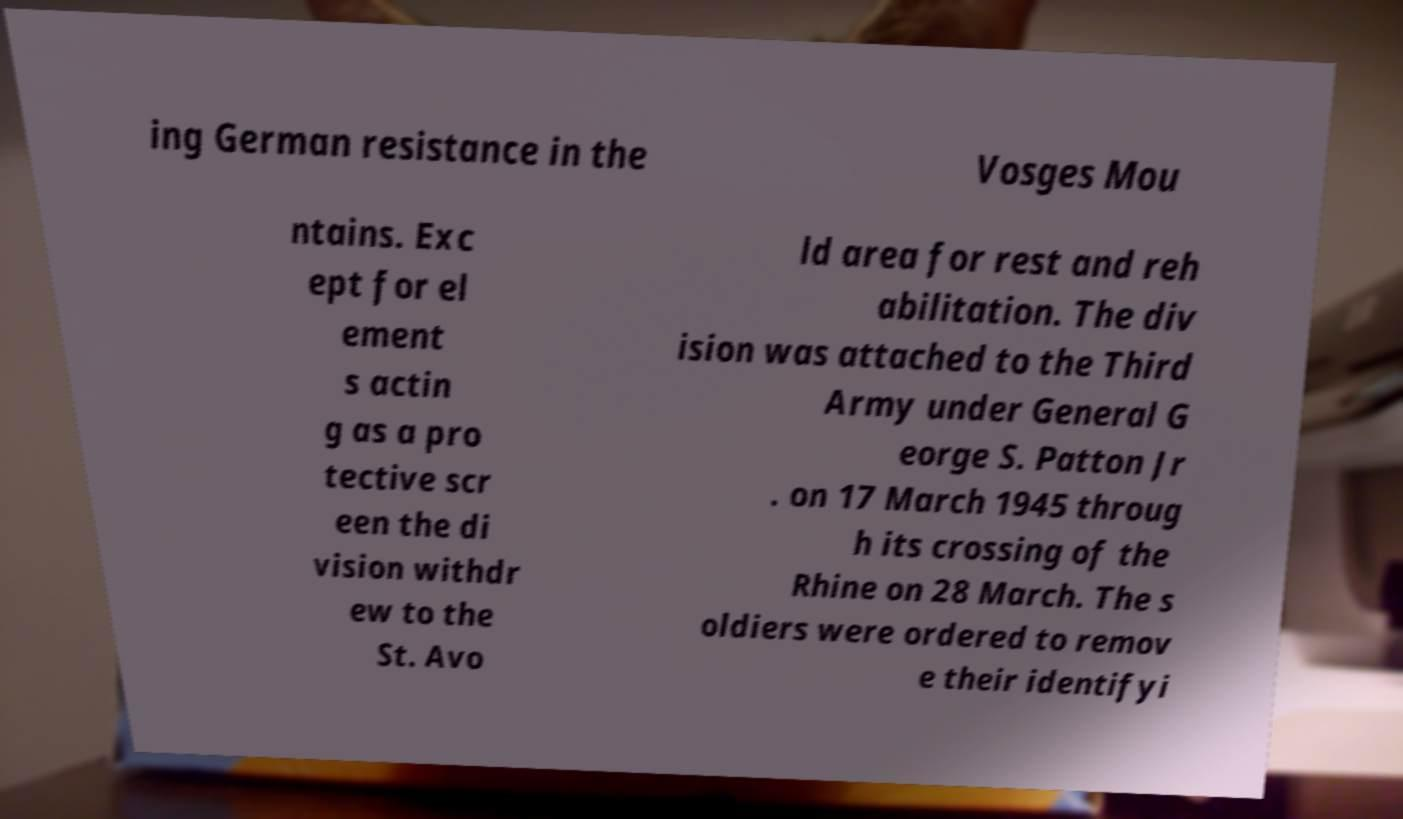For documentation purposes, I need the text within this image transcribed. Could you provide that? ing German resistance in the Vosges Mou ntains. Exc ept for el ement s actin g as a pro tective scr een the di vision withdr ew to the St. Avo ld area for rest and reh abilitation. The div ision was attached to the Third Army under General G eorge S. Patton Jr . on 17 March 1945 throug h its crossing of the Rhine on 28 March. The s oldiers were ordered to remov e their identifyi 